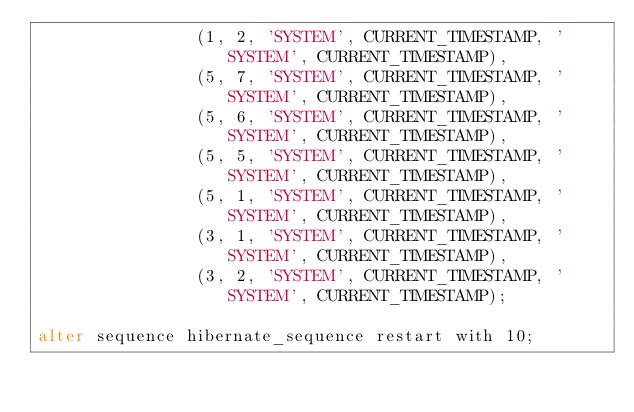<code> <loc_0><loc_0><loc_500><loc_500><_SQL_>                (1, 2, 'SYSTEM', CURRENT_TIMESTAMP, 'SYSTEM', CURRENT_TIMESTAMP),
                (5, 7, 'SYSTEM', CURRENT_TIMESTAMP, 'SYSTEM', CURRENT_TIMESTAMP),
                (5, 6, 'SYSTEM', CURRENT_TIMESTAMP, 'SYSTEM', CURRENT_TIMESTAMP),
                (5, 5, 'SYSTEM', CURRENT_TIMESTAMP, 'SYSTEM', CURRENT_TIMESTAMP),
                (5, 1, 'SYSTEM', CURRENT_TIMESTAMP, 'SYSTEM', CURRENT_TIMESTAMP),
                (3, 1, 'SYSTEM', CURRENT_TIMESTAMP, 'SYSTEM', CURRENT_TIMESTAMP),
                (3, 2, 'SYSTEM', CURRENT_TIMESTAMP, 'SYSTEM', CURRENT_TIMESTAMP);

alter sequence hibernate_sequence restart with 10;
</code> 